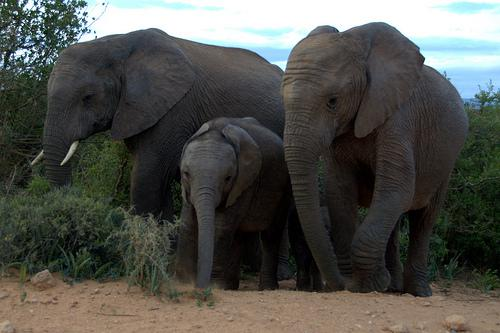Question: why is the elephant's left leg raised?
Choices:
A. Playing.
B. Being careful.
C. It is walking.
D. It is working.
Answer with the letter. Answer: C Question: what color are the elephants?
Choices:
A. Gray.
B. Brown.
C. Light gray.
D. Tan.
Answer with the letter. Answer: A Question: how many elephants?
Choices:
A. Four.
B. Five.
C. Six.
D. Three.
Answer with the letter. Answer: D Question: where are the elephant trunks?
Choices:
A. In the water.
B. In the dirt.
C. In the mud.
D. In the grass.
Answer with the letter. Answer: B Question: what is behind the elephants?
Choices:
A. Trees.
B. Rocks.
C. Water.
D. Bushes.
Answer with the letter. Answer: A 